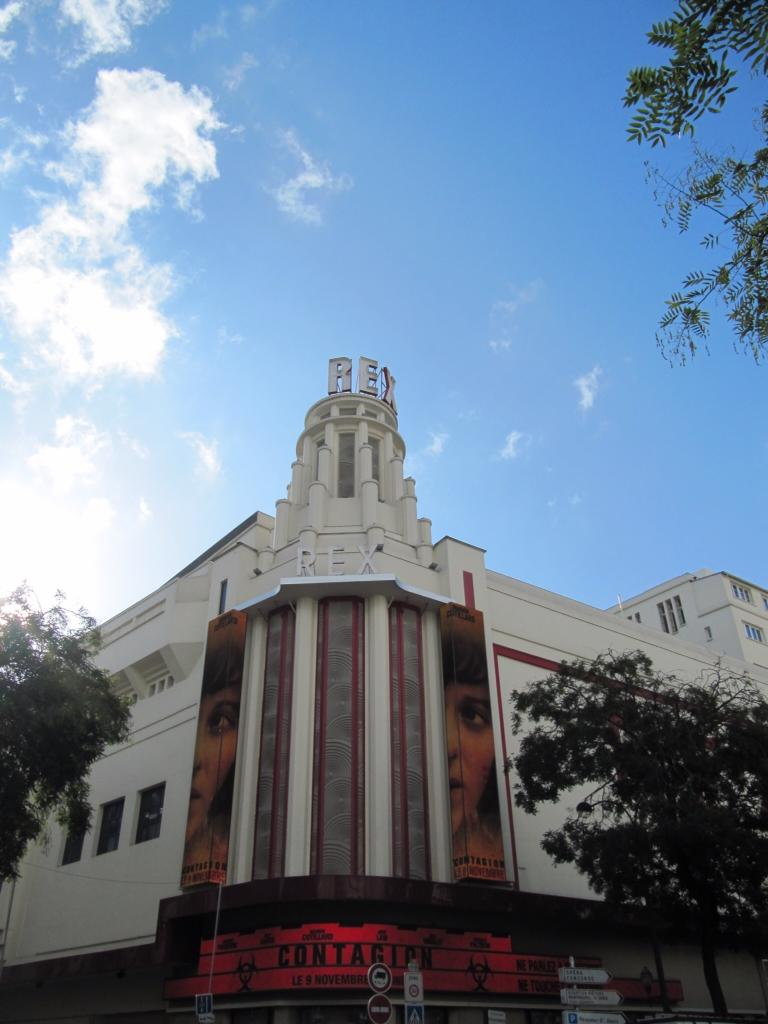Provide a one-sentence caption for the provided image. The advertisement for Contagion is in the front of a very tall building. 